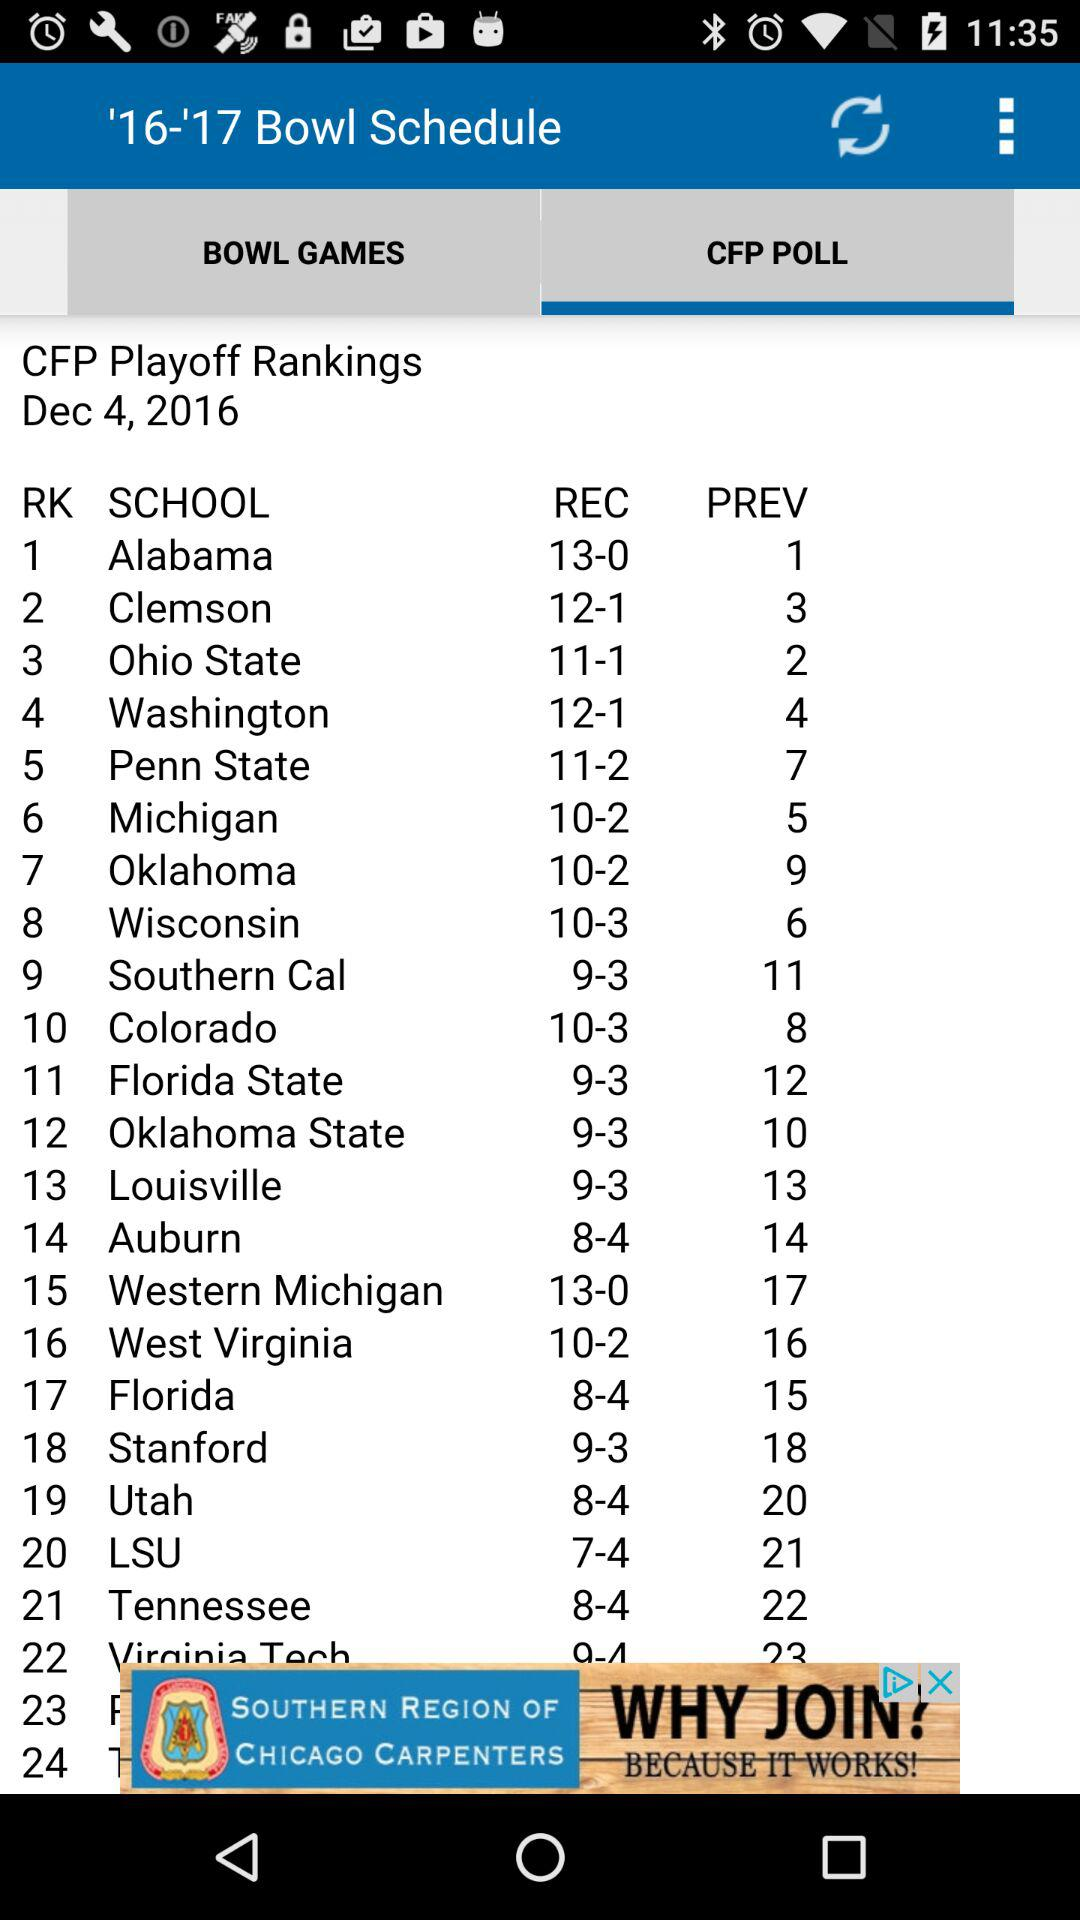What school ranks third? The school of Ohio State is ranked third. 